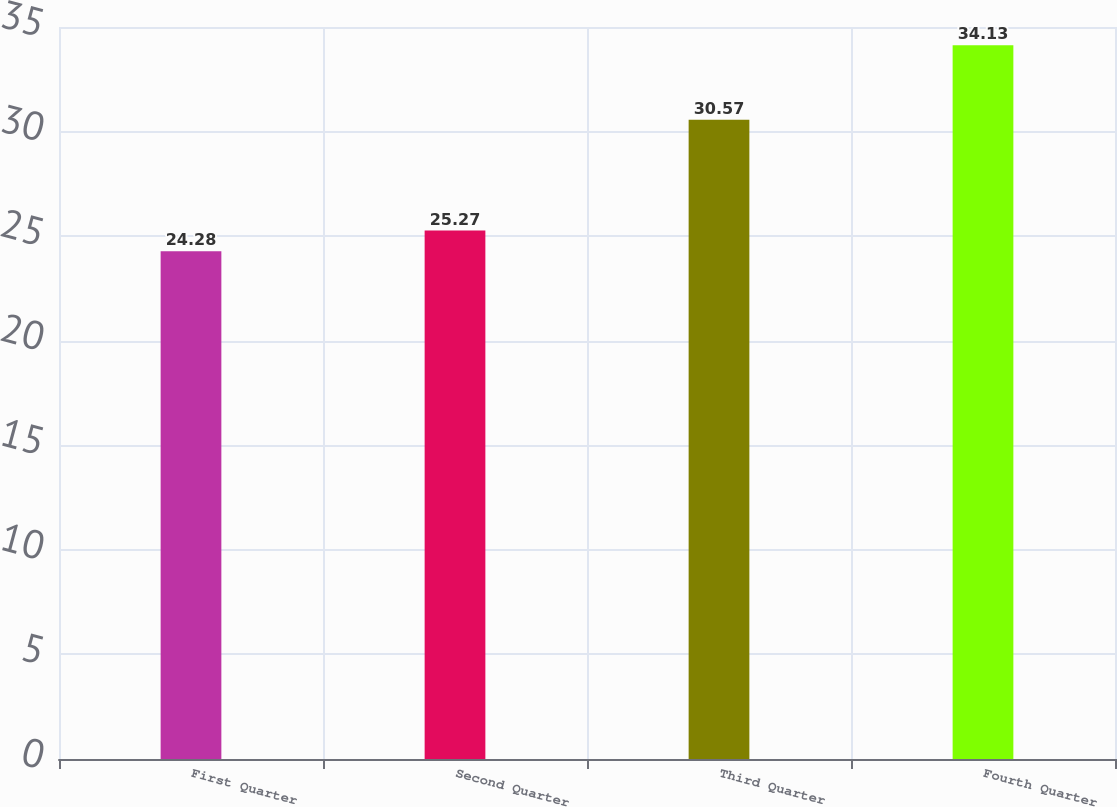Convert chart to OTSL. <chart><loc_0><loc_0><loc_500><loc_500><bar_chart><fcel>First Quarter<fcel>Second Quarter<fcel>Third Quarter<fcel>Fourth Quarter<nl><fcel>24.28<fcel>25.27<fcel>30.57<fcel>34.13<nl></chart> 